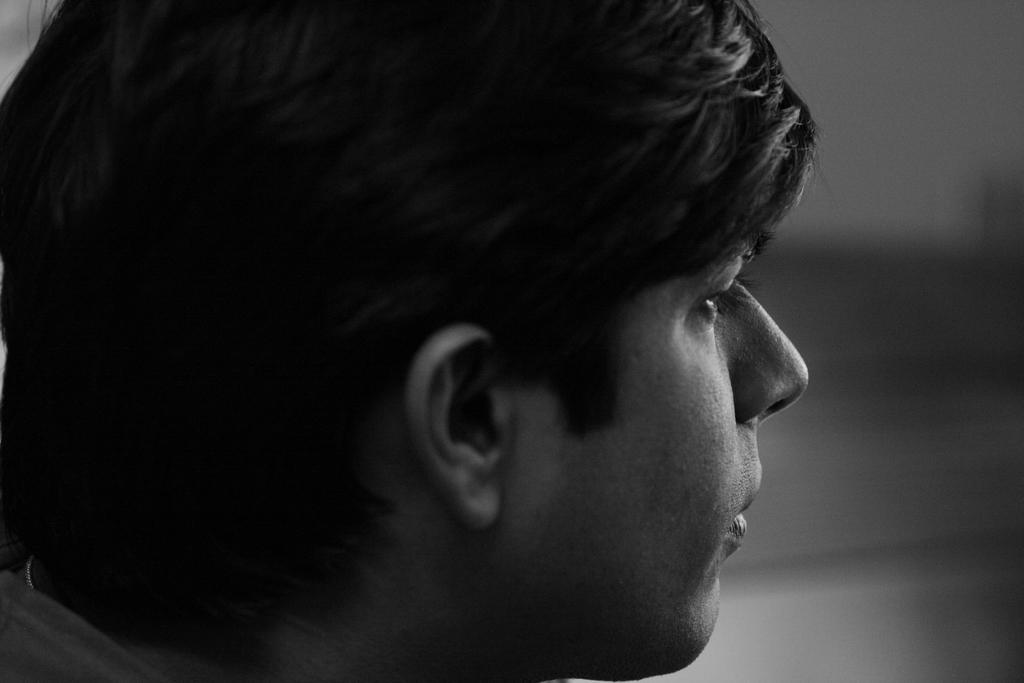What is the color scheme of the image? The image is black and white. What can be seen in the image? There is a side view of a man's head in the image. Can you describe the background of the image? The background of the image is blurred. What type of building can be seen in the background of the image? There is no building present in the image; it is a black and white image of a man's head with a blurred background. What is inside the jar that is visible in the image? There is no jar present in the image. 